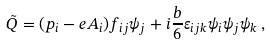<formula> <loc_0><loc_0><loc_500><loc_500>\tilde { Q } = ( p _ { i } - e A _ { i } ) f _ { i j } \psi _ { j } + i { \frac { b } { 6 } } \varepsilon _ { i j k } \psi _ { i } \psi _ { j } \psi _ { k } \, ,</formula> 